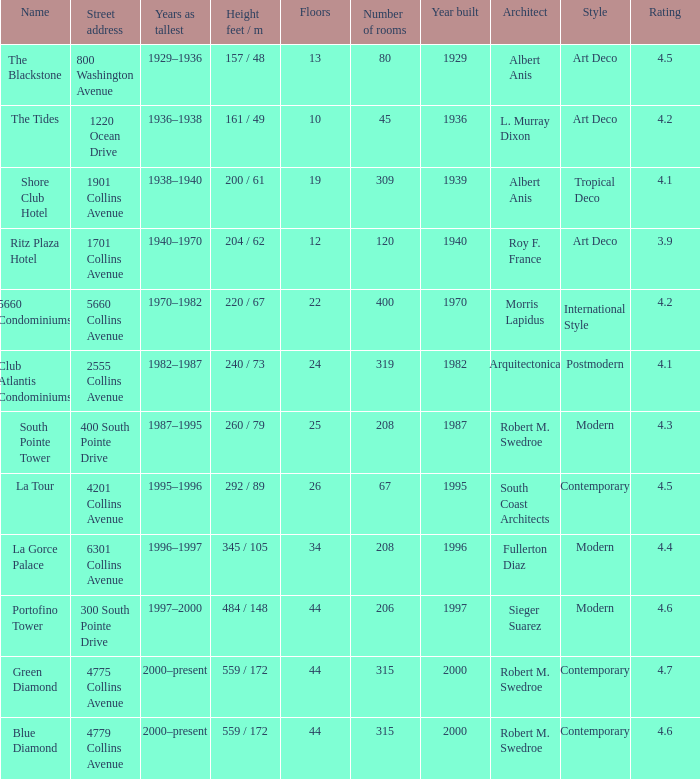How many floors does the Blue Diamond have? 44.0. 